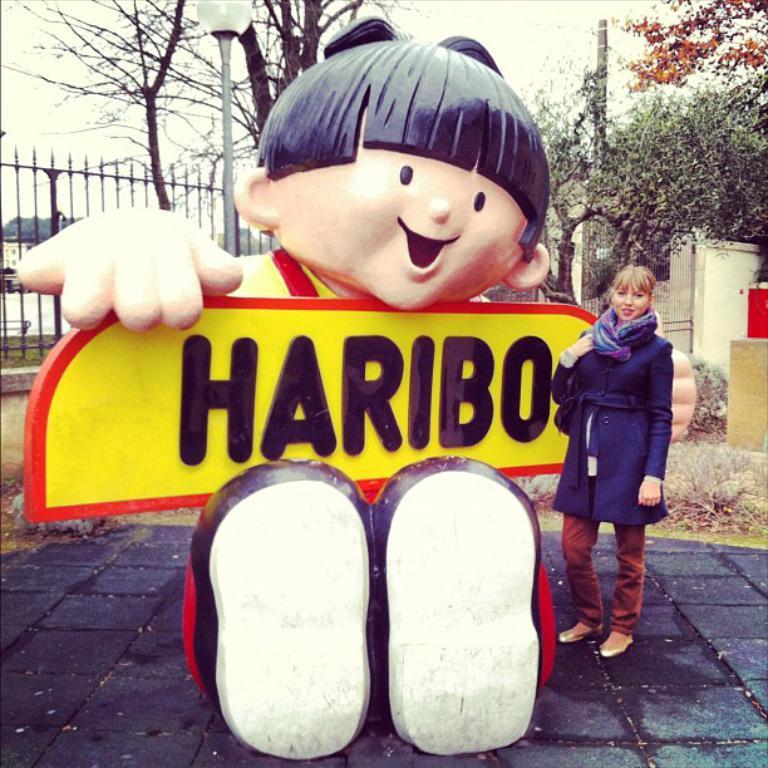Could you give a brief overview of what you see in this image? A woman is standing wearing a stole and a coat. There is a sculpture. There is fence, poles and trees at the back. 